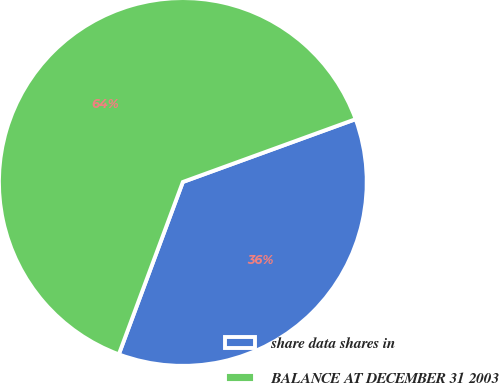Convert chart. <chart><loc_0><loc_0><loc_500><loc_500><pie_chart><fcel>share data shares in<fcel>BALANCE AT DECEMBER 31 2003<nl><fcel>36.21%<fcel>63.79%<nl></chart> 